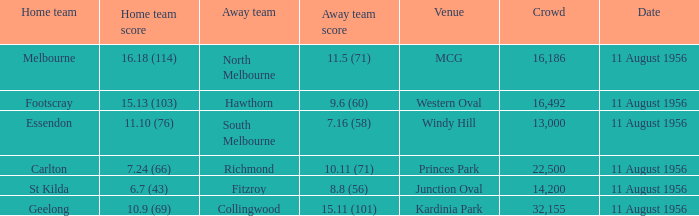What is the score for footscray's home team? 15.13 (103). 